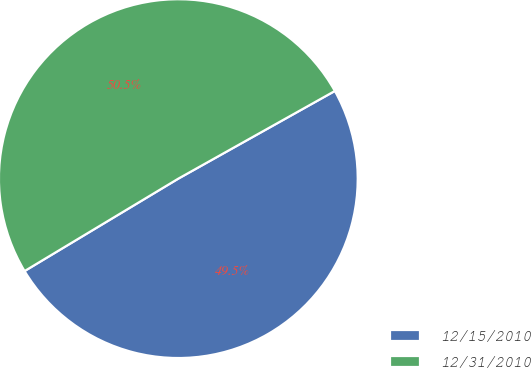Convert chart to OTSL. <chart><loc_0><loc_0><loc_500><loc_500><pie_chart><fcel>12/15/2010<fcel>12/31/2010<nl><fcel>49.51%<fcel>50.49%<nl></chart> 